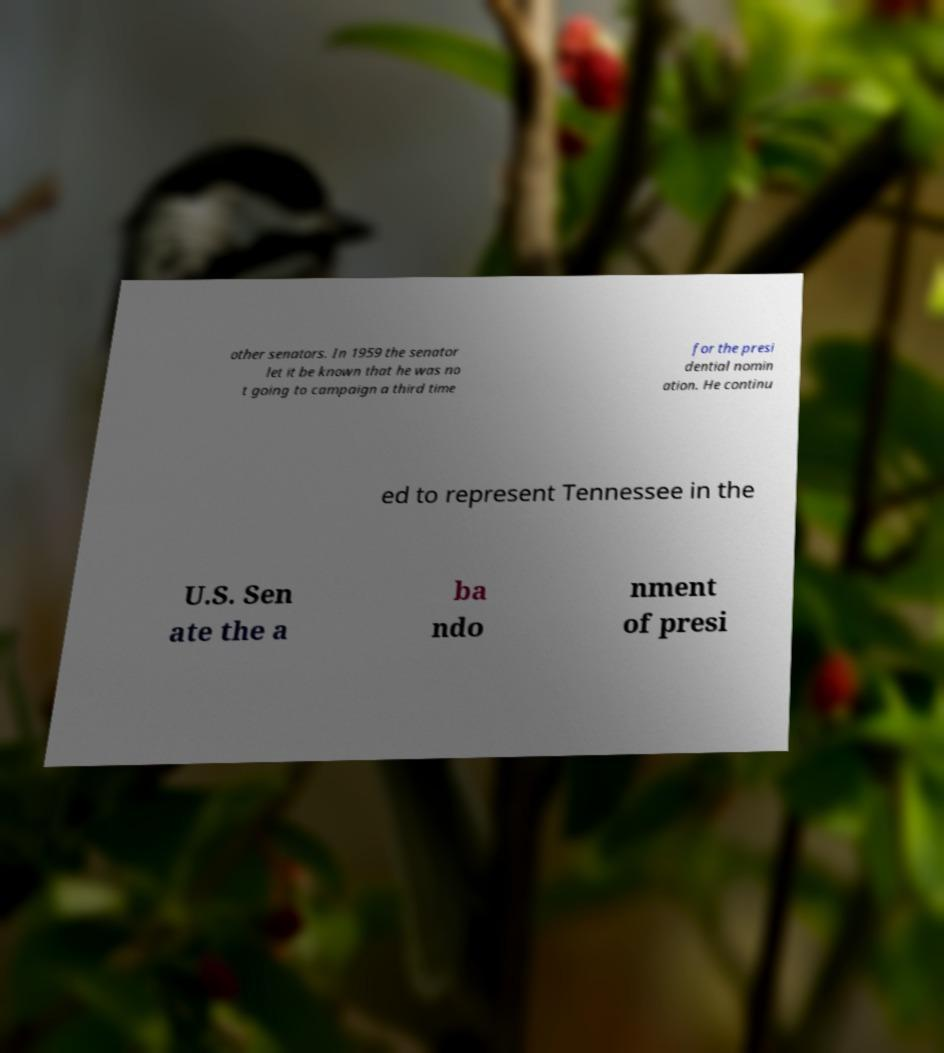Could you extract and type out the text from this image? other senators. In 1959 the senator let it be known that he was no t going to campaign a third time for the presi dential nomin ation. He continu ed to represent Tennessee in the U.S. Sen ate the a ba ndo nment of presi 